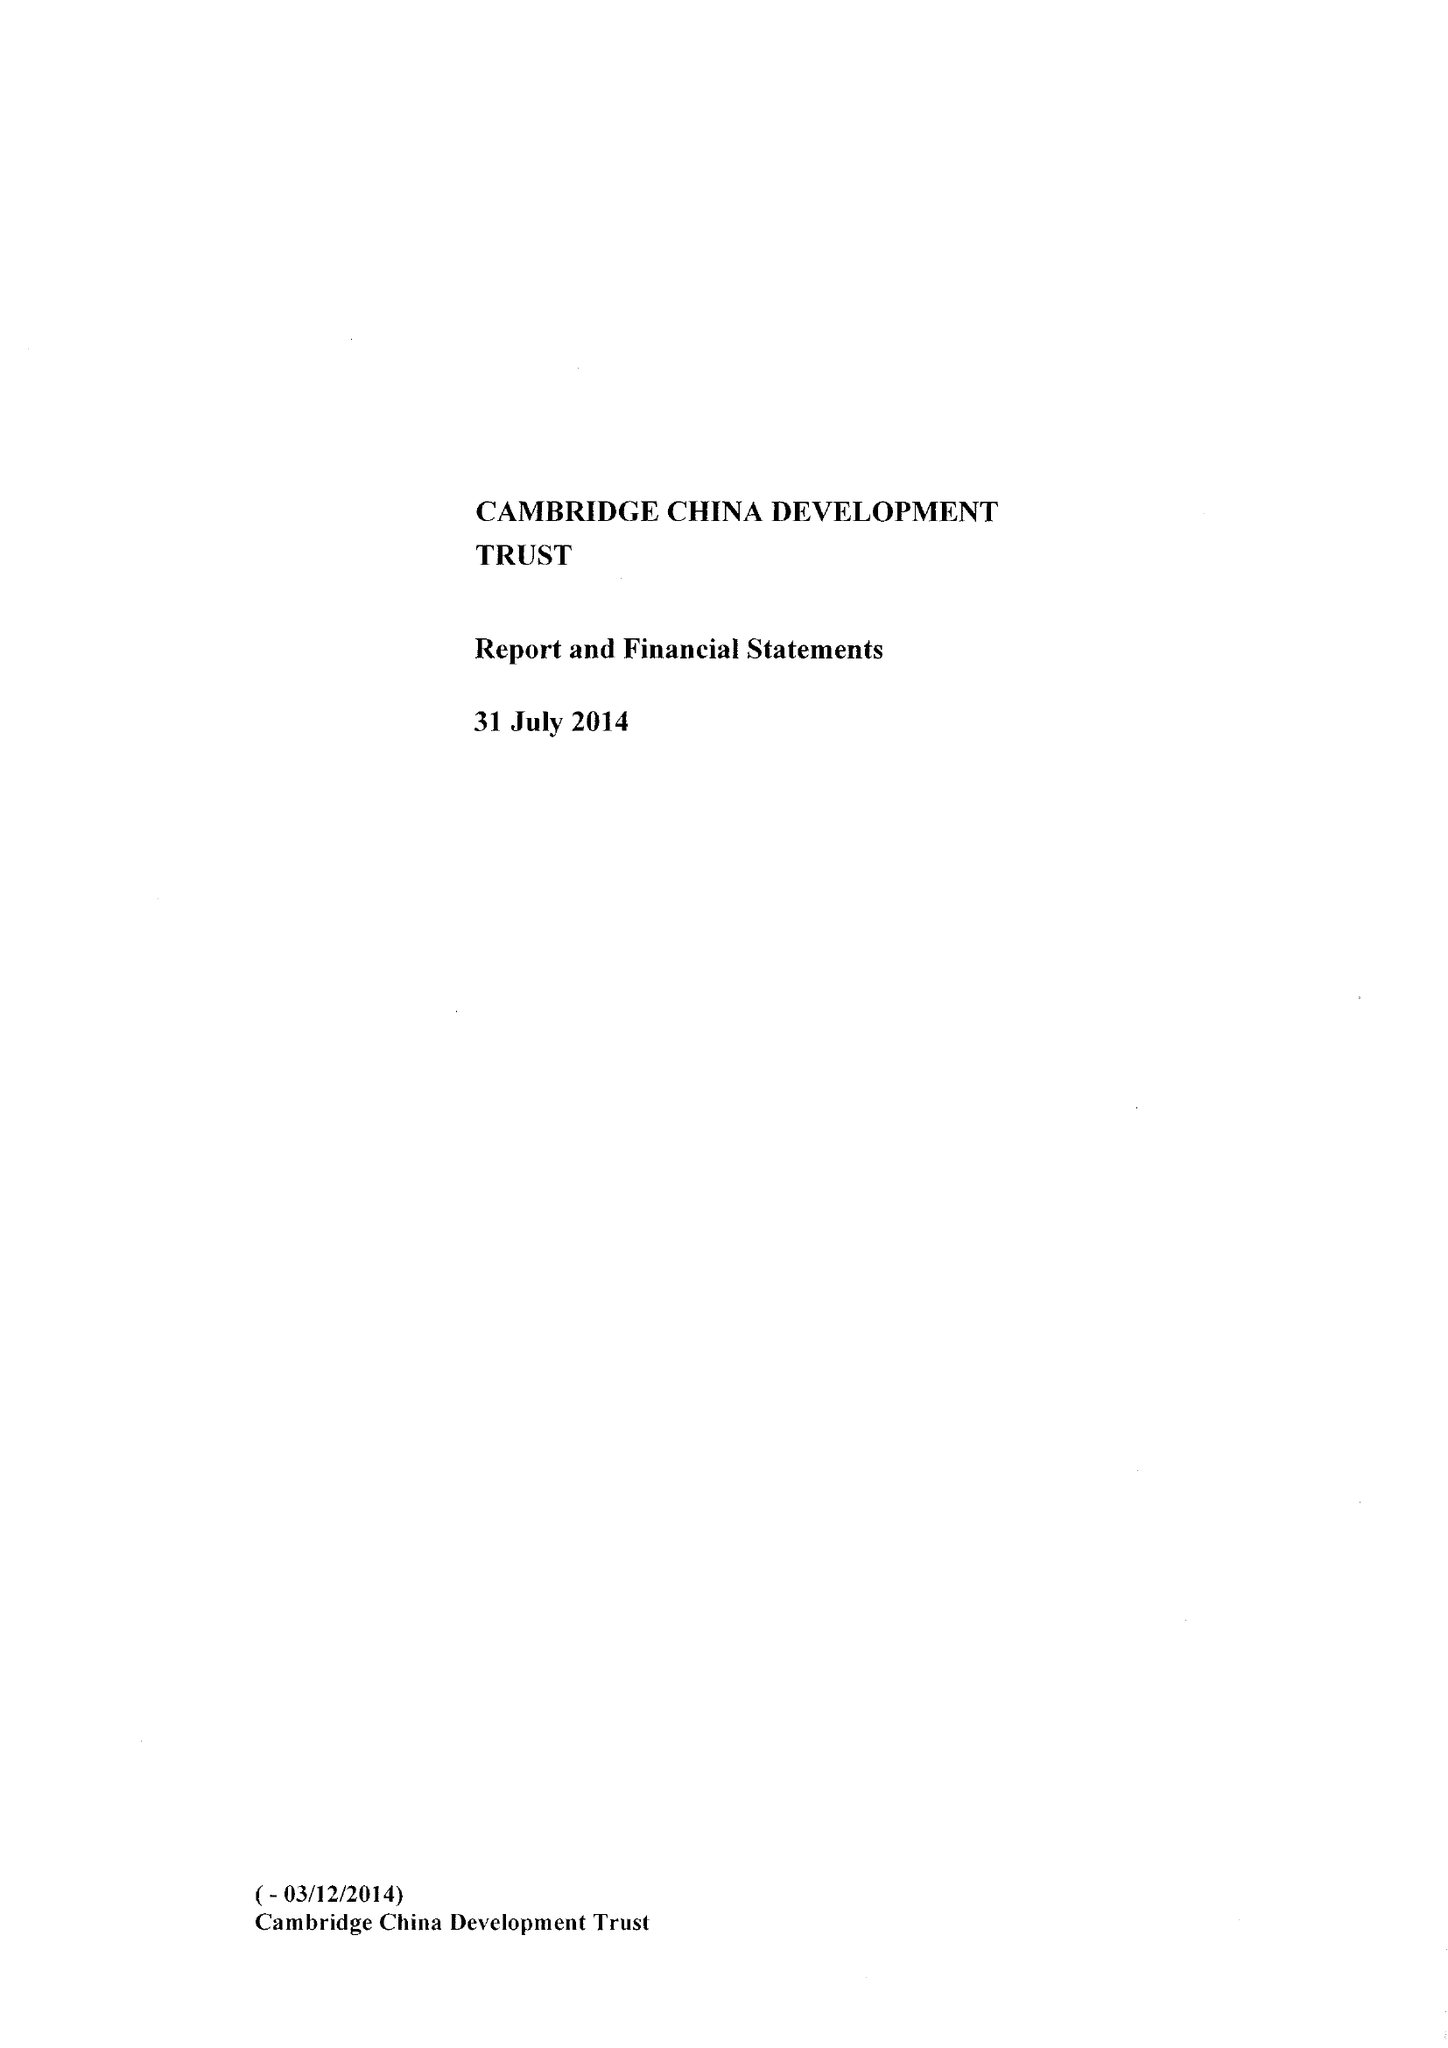What is the value for the income_annually_in_british_pounds?
Answer the question using a single word or phrase. 505317.00 